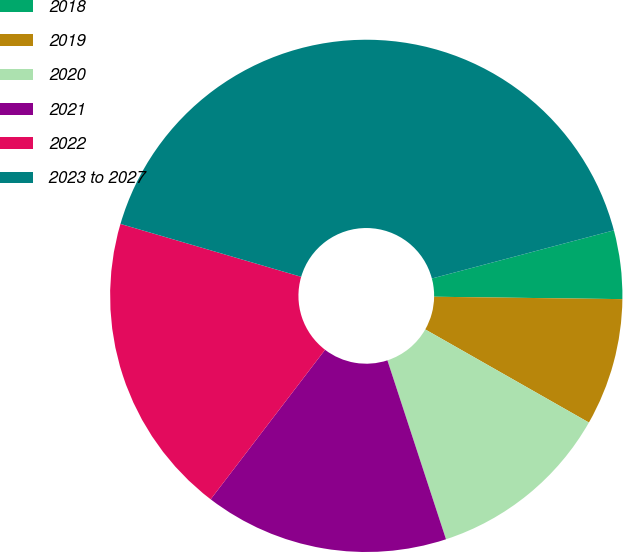Convert chart. <chart><loc_0><loc_0><loc_500><loc_500><pie_chart><fcel>2018<fcel>2019<fcel>2020<fcel>2021<fcel>2022<fcel>2023 to 2027<nl><fcel>4.32%<fcel>8.03%<fcel>11.73%<fcel>15.43%<fcel>19.14%<fcel>41.35%<nl></chart> 